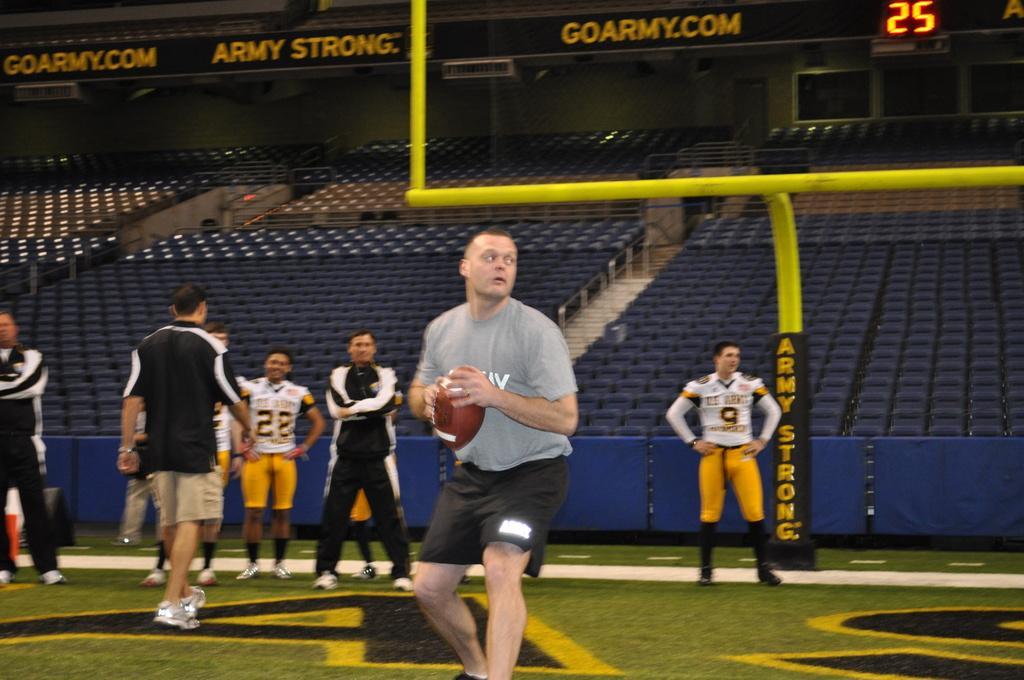Could you give a brief overview of what you see in this image? In this picture we can see some people standing here, a man in the front is holding a ball, at the bottom there is grass, we can see some chairs and stairs in the background, there is a rod here, we can see a digital display here. 